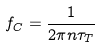<formula> <loc_0><loc_0><loc_500><loc_500>f _ { C } = \frac { 1 } { 2 \pi n \tau _ { T } }</formula> 